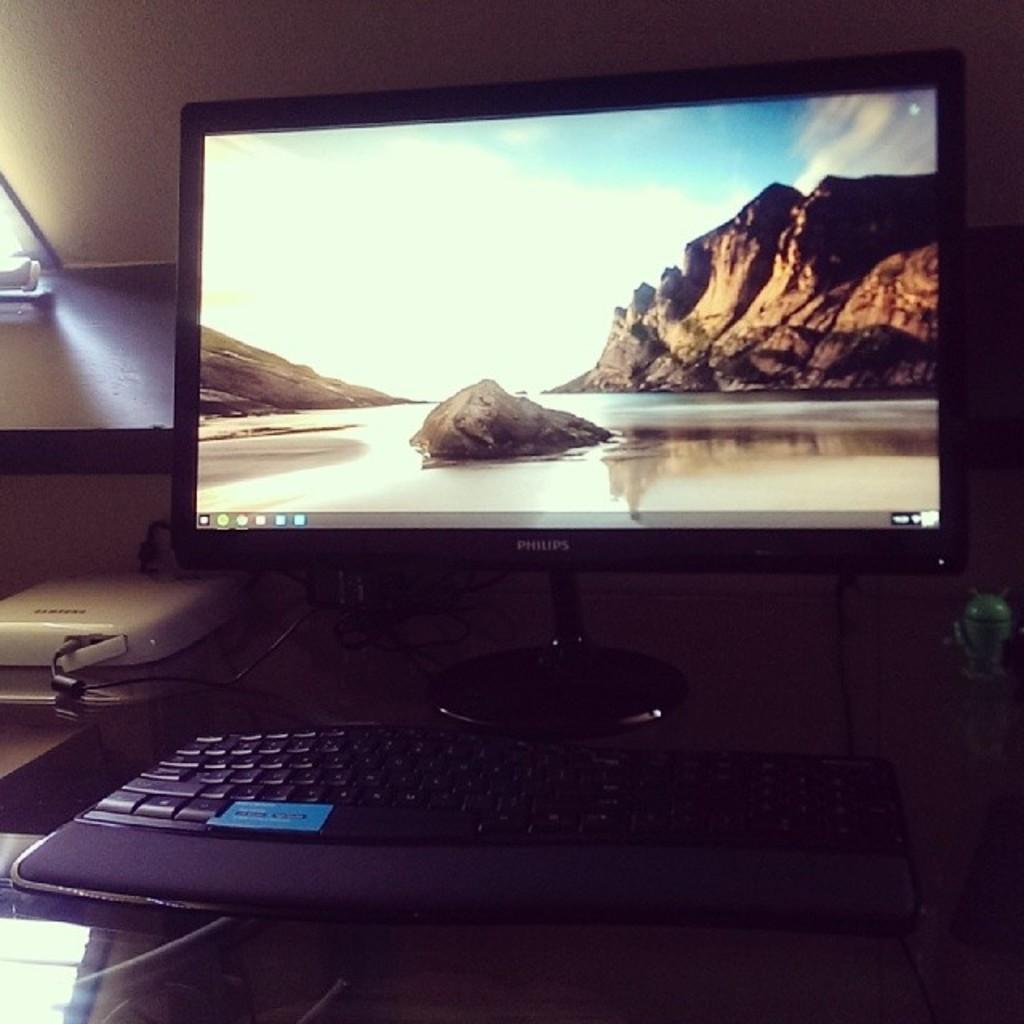Provide a one-sentence caption for the provided image. nA image of a shore and a cliff is on a Phillip's computer monitor. 